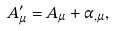<formula> <loc_0><loc_0><loc_500><loc_500>A ^ { \prime } _ { \mu } = A _ { \mu } + \alpha _ { , \mu } ,</formula> 